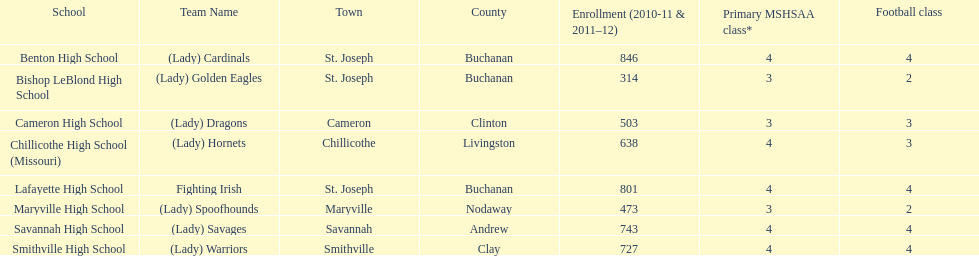Benton high school and bishop leblond high school are both located in what town? St. Joseph. Parse the table in full. {'header': ['School', 'Team Name', 'Town', 'County', 'Enrollment (2010-11 & 2011–12)', 'Primary MSHSAA class*', 'Football class'], 'rows': [['Benton High School', '(Lady) Cardinals', 'St. Joseph', 'Buchanan', '846', '4', '4'], ['Bishop LeBlond High School', '(Lady) Golden Eagles', 'St. Joseph', 'Buchanan', '314', '3', '2'], ['Cameron High School', '(Lady) Dragons', 'Cameron', 'Clinton', '503', '3', '3'], ['Chillicothe High School (Missouri)', '(Lady) Hornets', 'Chillicothe', 'Livingston', '638', '4', '3'], ['Lafayette High School', 'Fighting Irish', 'St. Joseph', 'Buchanan', '801', '4', '4'], ['Maryville High School', '(Lady) Spoofhounds', 'Maryville', 'Nodaway', '473', '3', '2'], ['Savannah High School', '(Lady) Savages', 'Savannah', 'Andrew', '743', '4', '4'], ['Smithville High School', '(Lady) Warriors', 'Smithville', 'Clay', '727', '4', '4']]} 